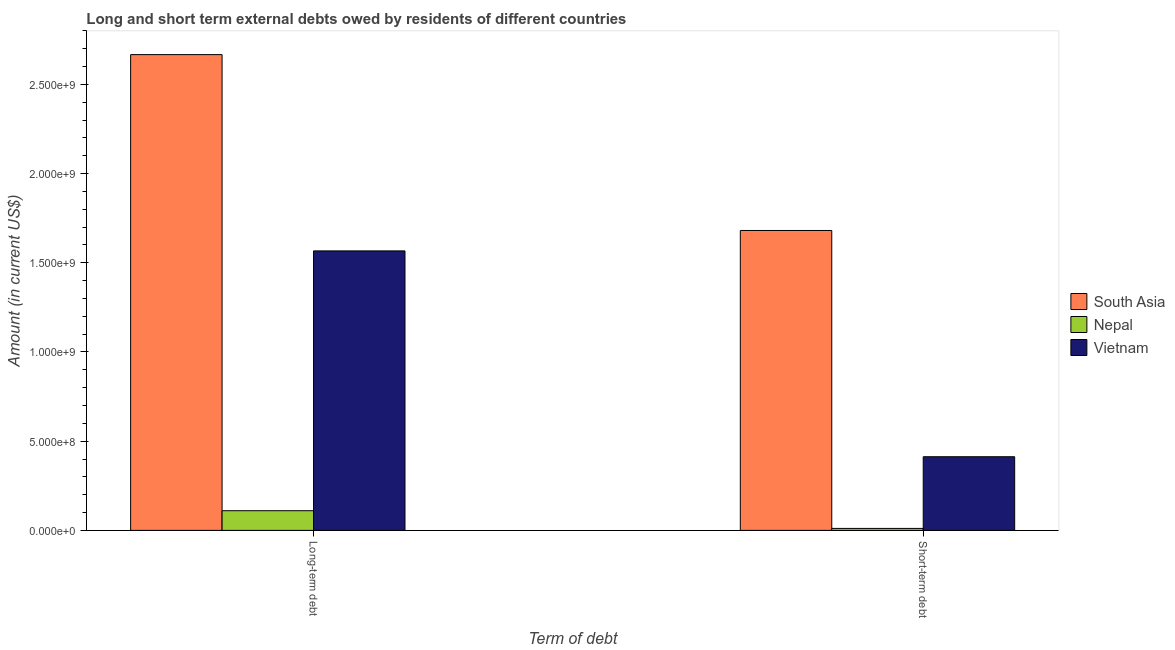Are the number of bars per tick equal to the number of legend labels?
Your response must be concise. Yes. Are the number of bars on each tick of the X-axis equal?
Make the answer very short. Yes. How many bars are there on the 2nd tick from the left?
Provide a short and direct response. 3. How many bars are there on the 2nd tick from the right?
Ensure brevity in your answer.  3. What is the label of the 2nd group of bars from the left?
Your answer should be very brief. Short-term debt. What is the short-term debts owed by residents in Nepal?
Your answer should be very brief. 1.10e+07. Across all countries, what is the maximum long-term debts owed by residents?
Ensure brevity in your answer.  2.67e+09. Across all countries, what is the minimum short-term debts owed by residents?
Offer a very short reply. 1.10e+07. In which country was the short-term debts owed by residents minimum?
Provide a short and direct response. Nepal. What is the total short-term debts owed by residents in the graph?
Your response must be concise. 2.11e+09. What is the difference between the short-term debts owed by residents in Vietnam and that in Nepal?
Offer a terse response. 4.02e+08. What is the difference between the long-term debts owed by residents in South Asia and the short-term debts owed by residents in Vietnam?
Ensure brevity in your answer.  2.25e+09. What is the average short-term debts owed by residents per country?
Your answer should be very brief. 7.02e+08. What is the difference between the short-term debts owed by residents and long-term debts owed by residents in Vietnam?
Your response must be concise. -1.15e+09. In how many countries, is the long-term debts owed by residents greater than 900000000 US$?
Offer a very short reply. 2. What is the ratio of the short-term debts owed by residents in South Asia to that in Vietnam?
Your answer should be compact. 4.07. What does the 1st bar from the right in Short-term debt represents?
Make the answer very short. Vietnam. Are all the bars in the graph horizontal?
Give a very brief answer. No. How many countries are there in the graph?
Provide a succinct answer. 3. Does the graph contain any zero values?
Ensure brevity in your answer.  No. Does the graph contain grids?
Your answer should be compact. No. What is the title of the graph?
Provide a succinct answer. Long and short term external debts owed by residents of different countries. Does "Israel" appear as one of the legend labels in the graph?
Give a very brief answer. No. What is the label or title of the X-axis?
Your answer should be very brief. Term of debt. What is the label or title of the Y-axis?
Offer a terse response. Amount (in current US$). What is the Amount (in current US$) in South Asia in Long-term debt?
Your answer should be very brief. 2.67e+09. What is the Amount (in current US$) in Nepal in Long-term debt?
Offer a very short reply. 1.10e+08. What is the Amount (in current US$) in Vietnam in Long-term debt?
Ensure brevity in your answer.  1.57e+09. What is the Amount (in current US$) in South Asia in Short-term debt?
Make the answer very short. 1.68e+09. What is the Amount (in current US$) of Nepal in Short-term debt?
Provide a succinct answer. 1.10e+07. What is the Amount (in current US$) in Vietnam in Short-term debt?
Ensure brevity in your answer.  4.13e+08. Across all Term of debt, what is the maximum Amount (in current US$) of South Asia?
Provide a succinct answer. 2.67e+09. Across all Term of debt, what is the maximum Amount (in current US$) in Nepal?
Your answer should be compact. 1.10e+08. Across all Term of debt, what is the maximum Amount (in current US$) of Vietnam?
Keep it short and to the point. 1.57e+09. Across all Term of debt, what is the minimum Amount (in current US$) in South Asia?
Your answer should be compact. 1.68e+09. Across all Term of debt, what is the minimum Amount (in current US$) of Nepal?
Your answer should be compact. 1.10e+07. Across all Term of debt, what is the minimum Amount (in current US$) in Vietnam?
Provide a short and direct response. 4.13e+08. What is the total Amount (in current US$) of South Asia in the graph?
Offer a terse response. 4.35e+09. What is the total Amount (in current US$) in Nepal in the graph?
Make the answer very short. 1.21e+08. What is the total Amount (in current US$) in Vietnam in the graph?
Your answer should be compact. 1.98e+09. What is the difference between the Amount (in current US$) of South Asia in Long-term debt and that in Short-term debt?
Offer a terse response. 9.86e+08. What is the difference between the Amount (in current US$) of Nepal in Long-term debt and that in Short-term debt?
Your answer should be compact. 9.93e+07. What is the difference between the Amount (in current US$) of Vietnam in Long-term debt and that in Short-term debt?
Offer a very short reply. 1.15e+09. What is the difference between the Amount (in current US$) in South Asia in Long-term debt and the Amount (in current US$) in Nepal in Short-term debt?
Provide a succinct answer. 2.66e+09. What is the difference between the Amount (in current US$) of South Asia in Long-term debt and the Amount (in current US$) of Vietnam in Short-term debt?
Provide a succinct answer. 2.25e+09. What is the difference between the Amount (in current US$) of Nepal in Long-term debt and the Amount (in current US$) of Vietnam in Short-term debt?
Make the answer very short. -3.03e+08. What is the average Amount (in current US$) of South Asia per Term of debt?
Give a very brief answer. 2.17e+09. What is the average Amount (in current US$) in Nepal per Term of debt?
Provide a succinct answer. 6.06e+07. What is the average Amount (in current US$) in Vietnam per Term of debt?
Your response must be concise. 9.90e+08. What is the difference between the Amount (in current US$) in South Asia and Amount (in current US$) in Nepal in Long-term debt?
Keep it short and to the point. 2.56e+09. What is the difference between the Amount (in current US$) in South Asia and Amount (in current US$) in Vietnam in Long-term debt?
Offer a very short reply. 1.10e+09. What is the difference between the Amount (in current US$) in Nepal and Amount (in current US$) in Vietnam in Long-term debt?
Make the answer very short. -1.46e+09. What is the difference between the Amount (in current US$) in South Asia and Amount (in current US$) in Nepal in Short-term debt?
Give a very brief answer. 1.67e+09. What is the difference between the Amount (in current US$) in South Asia and Amount (in current US$) in Vietnam in Short-term debt?
Your answer should be compact. 1.27e+09. What is the difference between the Amount (in current US$) in Nepal and Amount (in current US$) in Vietnam in Short-term debt?
Keep it short and to the point. -4.02e+08. What is the ratio of the Amount (in current US$) in South Asia in Long-term debt to that in Short-term debt?
Your answer should be very brief. 1.59. What is the ratio of the Amount (in current US$) in Nepal in Long-term debt to that in Short-term debt?
Your answer should be compact. 10.02. What is the ratio of the Amount (in current US$) of Vietnam in Long-term debt to that in Short-term debt?
Provide a succinct answer. 3.79. What is the difference between the highest and the second highest Amount (in current US$) of South Asia?
Provide a short and direct response. 9.86e+08. What is the difference between the highest and the second highest Amount (in current US$) in Nepal?
Provide a succinct answer. 9.93e+07. What is the difference between the highest and the second highest Amount (in current US$) of Vietnam?
Provide a short and direct response. 1.15e+09. What is the difference between the highest and the lowest Amount (in current US$) of South Asia?
Provide a succinct answer. 9.86e+08. What is the difference between the highest and the lowest Amount (in current US$) in Nepal?
Make the answer very short. 9.93e+07. What is the difference between the highest and the lowest Amount (in current US$) in Vietnam?
Your answer should be very brief. 1.15e+09. 